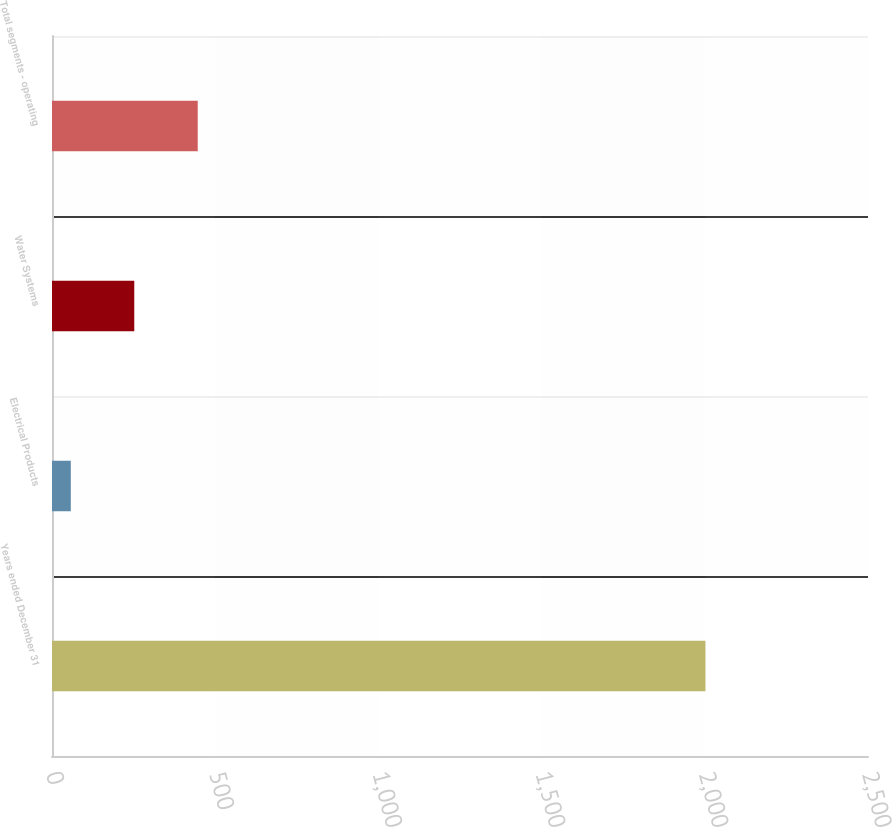Convert chart. <chart><loc_0><loc_0><loc_500><loc_500><bar_chart><fcel>Years ended December 31<fcel>Electrical Products<fcel>Water Systems<fcel>Total segments - operating<nl><fcel>2002<fcel>57.6<fcel>252.04<fcel>446.48<nl></chart> 